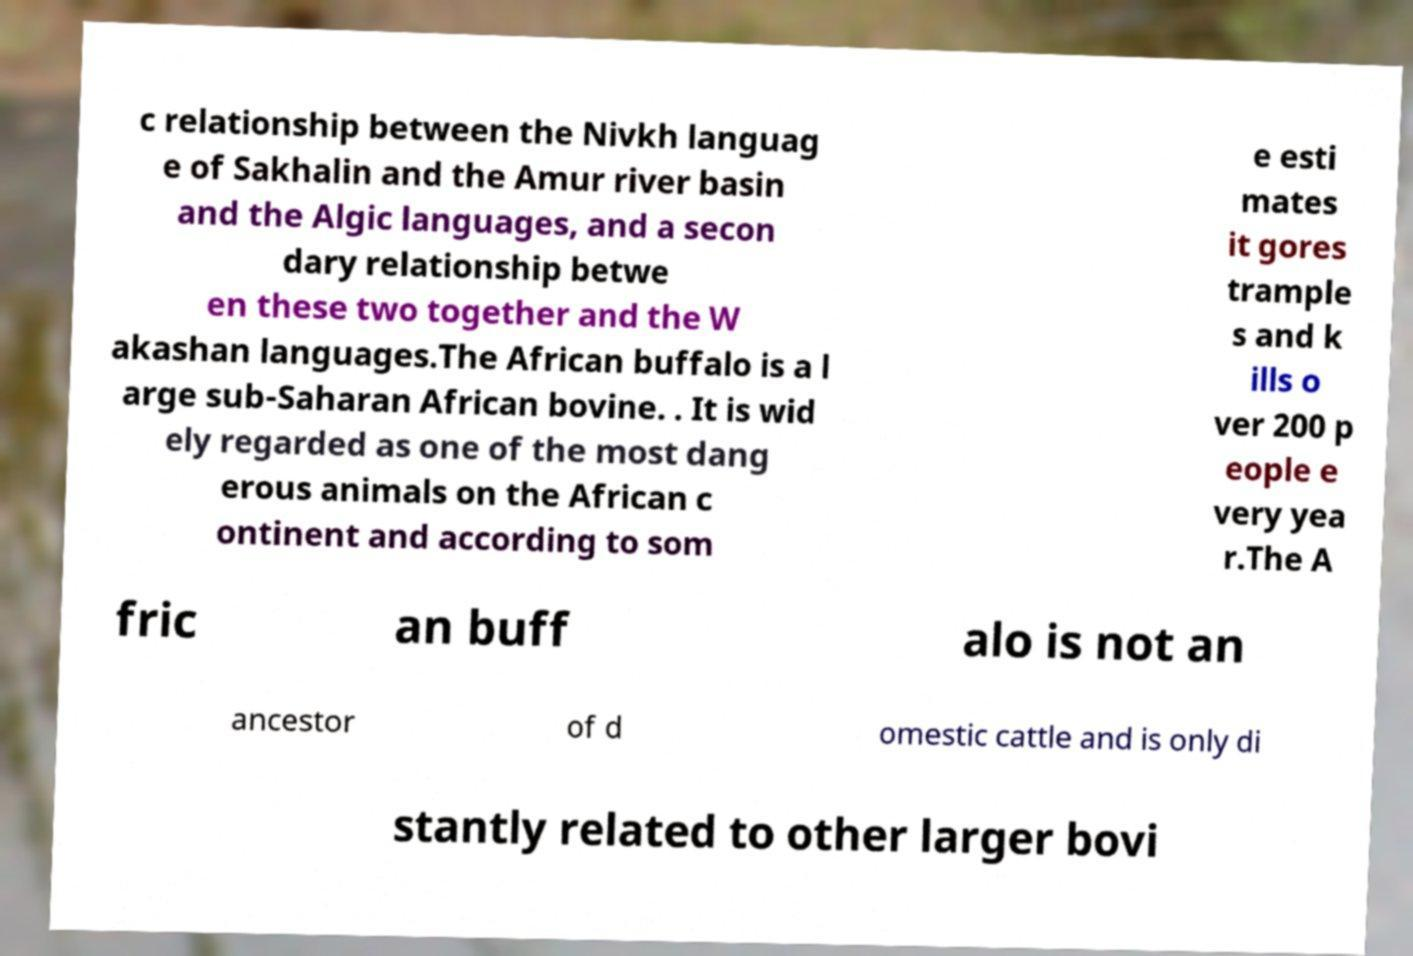Please identify and transcribe the text found in this image. c relationship between the Nivkh languag e of Sakhalin and the Amur river basin and the Algic languages, and a secon dary relationship betwe en these two together and the W akashan languages.The African buffalo is a l arge sub-Saharan African bovine. . It is wid ely regarded as one of the most dang erous animals on the African c ontinent and according to som e esti mates it gores trample s and k ills o ver 200 p eople e very yea r.The A fric an buff alo is not an ancestor of d omestic cattle and is only di stantly related to other larger bovi 